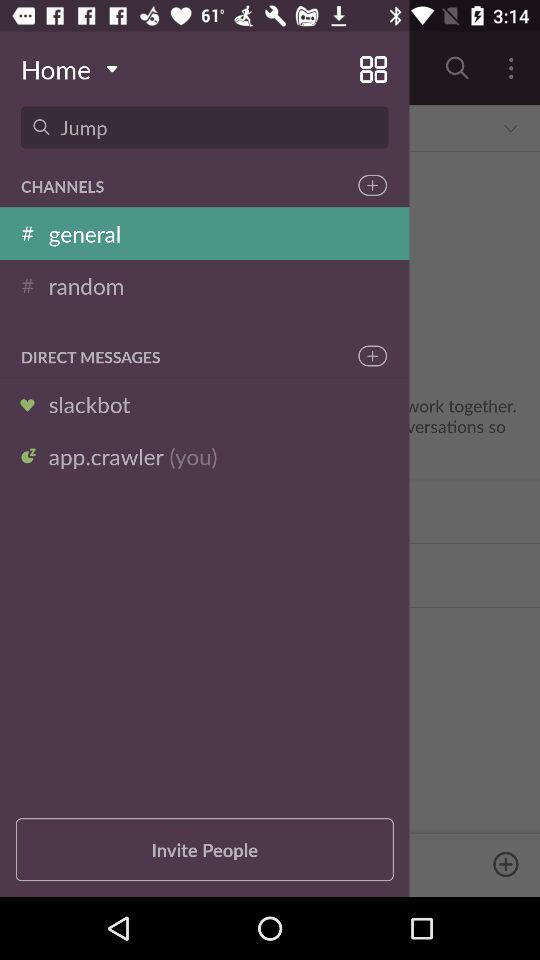How many people can we invite?
When the provided information is insufficient, respond with <no answer>. <no answer> 